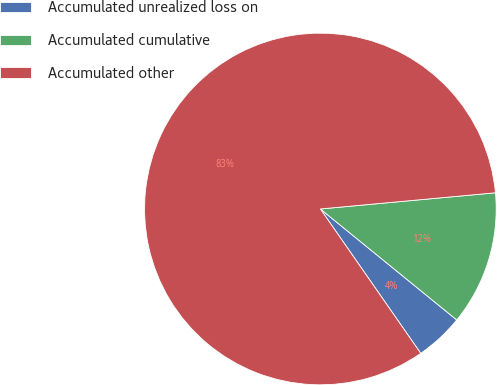Convert chart to OTSL. <chart><loc_0><loc_0><loc_500><loc_500><pie_chart><fcel>Accumulated unrealized loss on<fcel>Accumulated cumulative<fcel>Accumulated other<nl><fcel>4.46%<fcel>12.34%<fcel>83.2%<nl></chart> 